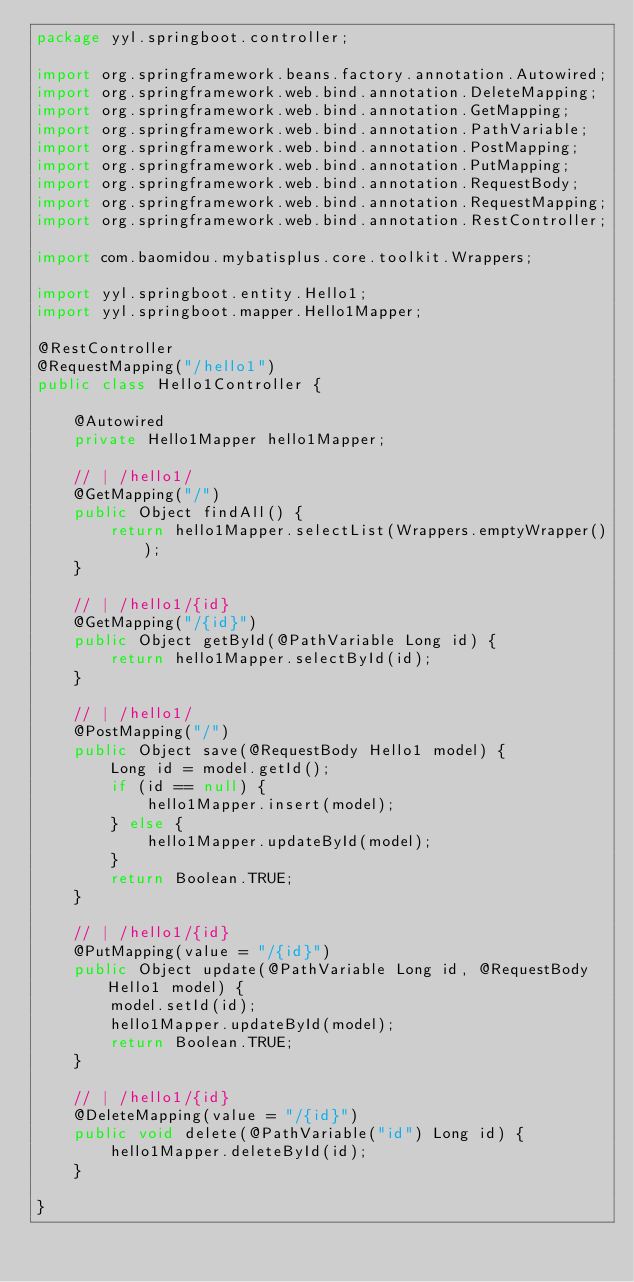Convert code to text. <code><loc_0><loc_0><loc_500><loc_500><_Java_>package yyl.springboot.controller;

import org.springframework.beans.factory.annotation.Autowired;
import org.springframework.web.bind.annotation.DeleteMapping;
import org.springframework.web.bind.annotation.GetMapping;
import org.springframework.web.bind.annotation.PathVariable;
import org.springframework.web.bind.annotation.PostMapping;
import org.springframework.web.bind.annotation.PutMapping;
import org.springframework.web.bind.annotation.RequestBody;
import org.springframework.web.bind.annotation.RequestMapping;
import org.springframework.web.bind.annotation.RestController;

import com.baomidou.mybatisplus.core.toolkit.Wrappers;

import yyl.springboot.entity.Hello1;
import yyl.springboot.mapper.Hello1Mapper;

@RestController
@RequestMapping("/hello1")
public class Hello1Controller {

    @Autowired
    private Hello1Mapper hello1Mapper;

    // | /hello1/
    @GetMapping("/")
    public Object findAll() {
        return hello1Mapper.selectList(Wrappers.emptyWrapper());
    }

    // | /hello1/{id}
    @GetMapping("/{id}")
    public Object getById(@PathVariable Long id) {
        return hello1Mapper.selectById(id);
    }

    // | /hello1/
    @PostMapping("/")
    public Object save(@RequestBody Hello1 model) {
        Long id = model.getId();
        if (id == null) {
            hello1Mapper.insert(model);
        } else {
            hello1Mapper.updateById(model);
        }
        return Boolean.TRUE;
    }

    // | /hello1/{id}
    @PutMapping(value = "/{id}")
    public Object update(@PathVariable Long id, @RequestBody Hello1 model) {
        model.setId(id);
        hello1Mapper.updateById(model);
        return Boolean.TRUE;
    }

    // | /hello1/{id}
    @DeleteMapping(value = "/{id}")
    public void delete(@PathVariable("id") Long id) {
        hello1Mapper.deleteById(id);
    }

}
</code> 